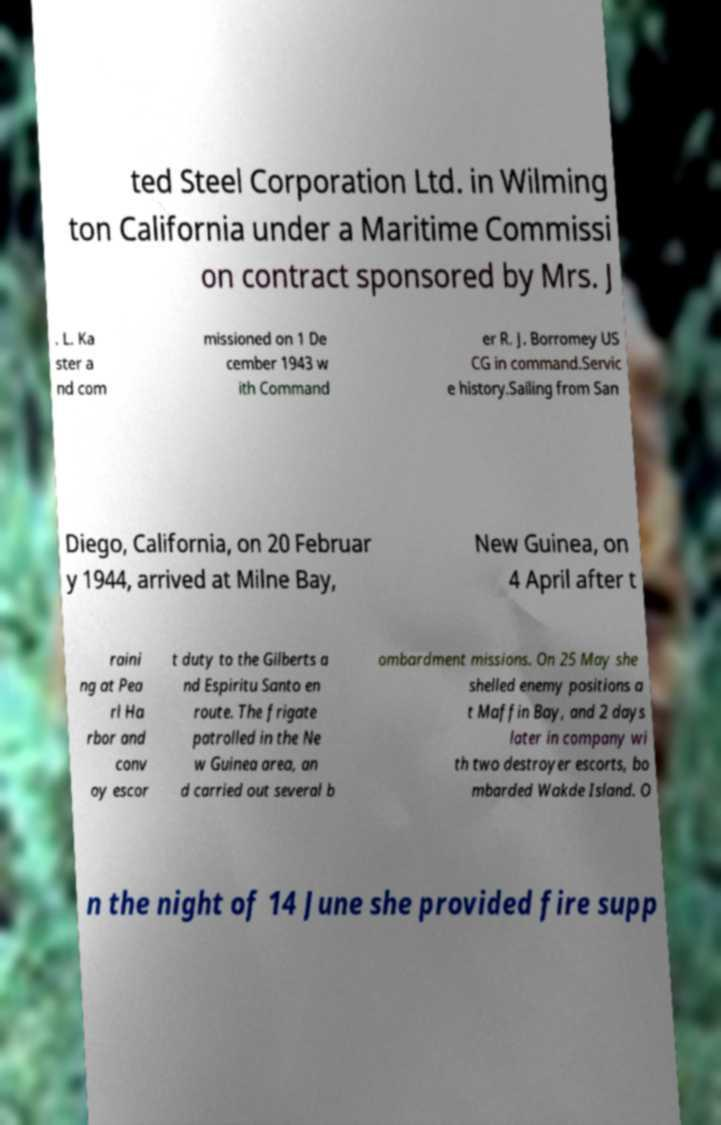Can you accurately transcribe the text from the provided image for me? ted Steel Corporation Ltd. in Wilming ton California under a Maritime Commissi on contract sponsored by Mrs. J . L. Ka ster a nd com missioned on 1 De cember 1943 w ith Command er R. J. Borromey US CG in command.Servic e history.Sailing from San Diego, California, on 20 Februar y 1944, arrived at Milne Bay, New Guinea, on 4 April after t raini ng at Pea rl Ha rbor and conv oy escor t duty to the Gilberts a nd Espiritu Santo en route. The frigate patrolled in the Ne w Guinea area, an d carried out several b ombardment missions. On 25 May she shelled enemy positions a t Maffin Bay, and 2 days later in company wi th two destroyer escorts, bo mbarded Wakde Island. O n the night of 14 June she provided fire supp 